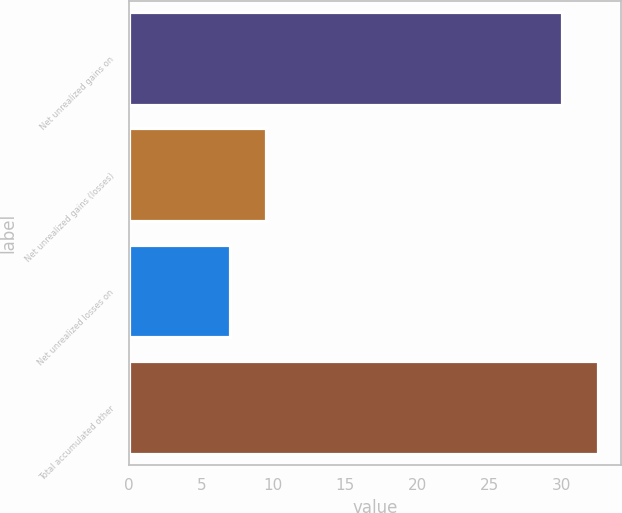Convert chart to OTSL. <chart><loc_0><loc_0><loc_500><loc_500><bar_chart><fcel>Net unrealized gains on<fcel>Net unrealized gains (losses)<fcel>Net unrealized losses on<fcel>Total accumulated other<nl><fcel>30<fcel>9.5<fcel>7<fcel>32.5<nl></chart> 